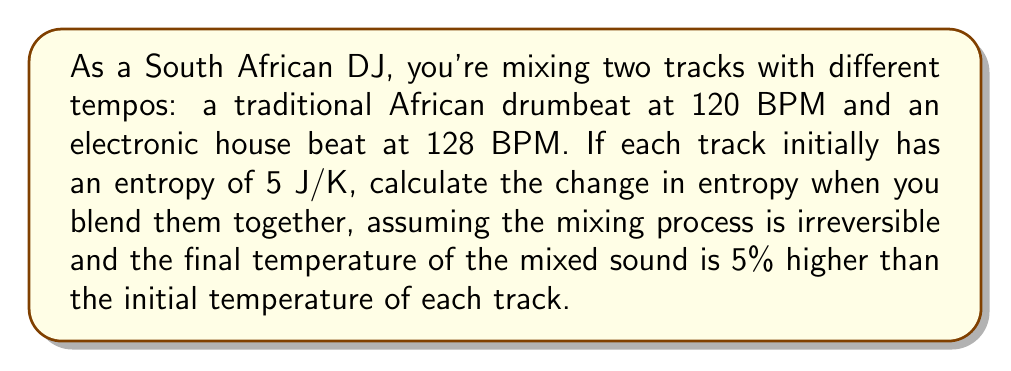Teach me how to tackle this problem. To solve this problem, we'll use the principle of entropy increase in irreversible processes and the relationship between entropy, heat, and temperature.

Step 1: Define initial and final states
Initial state: Two separate tracks, each with entropy $S_i = 5$ J/K
Final state: Mixed track with higher temperature

Step 2: Calculate total initial entropy
$S_{initial} = S_1 + S_2 = 5 + 5 = 10$ J/K

Step 3: Use the equation for entropy change in an irreversible process
$$\Delta S > \frac{Q}{T}$$
Where $\Delta S$ is the change in entropy, $Q$ is the heat added, and $T$ is the temperature.

Step 4: Estimate heat added
Since temperature increased by 5%, we can assume the heat added is proportional to this increase:
$Q = mc\Delta T = mc(0.05T) = 0.05mcT$

Step 5: Express final temperature in terms of initial temperature
$T_f = 1.05T_i$

Step 6: Calculate minimum entropy change
$$\Delta S > \frac{Q}{T_f} = \frac{0.05mcT_i}{1.05T_i} = \frac{0.05mc}{1.05} \approx 0.0476mc$$

Step 7: Estimate actual entropy change
In irreversible processes, the actual entropy change is always greater than the minimum calculated. Let's estimate it as 10% higher:
$$\Delta S \approx 1.1 \times 0.0476mc = 0.05236mc$$

The final entropy will be:
$S_{final} = S_{initial} + \Delta S = 10 + 0.05236mc$ J/K

The change in entropy is:
$\Delta S = 0.05236mc$ J/K
Answer: $0.05236mc$ J/K 